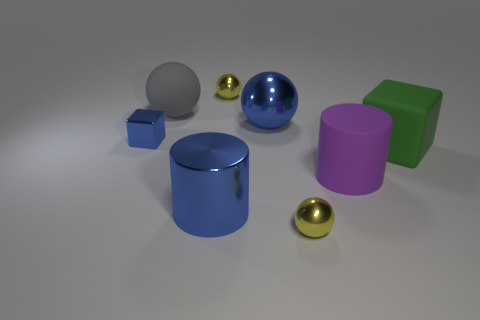Do the blue metal thing that is left of the gray matte sphere and the large green thing have the same shape?
Your answer should be very brief. Yes. Are there more metal blocks to the left of the green cube than small shiny cylinders?
Keep it short and to the point. Yes. What number of metal things are both right of the shiny cube and behind the large purple matte cylinder?
Make the answer very short. 2. The sphere that is in front of the big block that is behind the big rubber cylinder is what color?
Offer a very short reply. Yellow. How many objects are the same color as the large metal cylinder?
Ensure brevity in your answer.  2. There is a small block; does it have the same color as the cylinder left of the large blue ball?
Give a very brief answer. Yes. Are there fewer blocks than rubber objects?
Offer a very short reply. Yes. Is the number of big purple rubber cylinders that are behind the big metallic cylinder greater than the number of blue spheres behind the matte sphere?
Your answer should be compact. Yes. Do the big purple cylinder and the green block have the same material?
Provide a short and direct response. Yes. There is a yellow thing in front of the gray rubber thing; what number of tiny cubes are in front of it?
Keep it short and to the point. 0. 